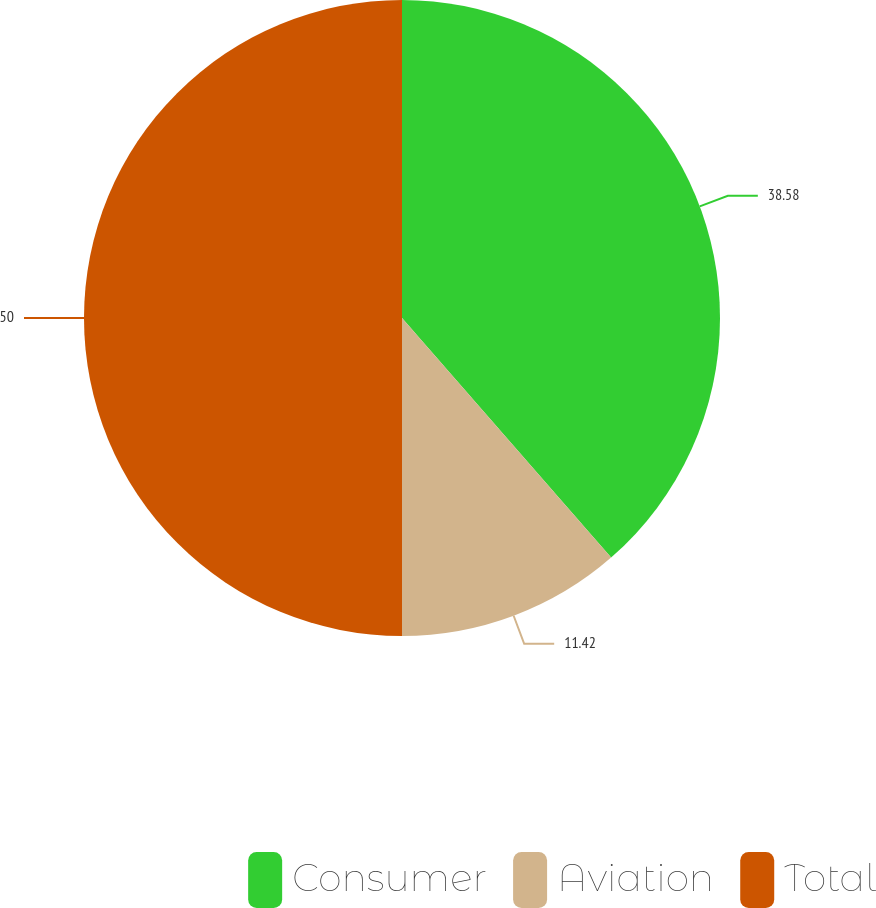<chart> <loc_0><loc_0><loc_500><loc_500><pie_chart><fcel>Consumer<fcel>Aviation<fcel>Total<nl><fcel>38.58%<fcel>11.42%<fcel>50.0%<nl></chart> 